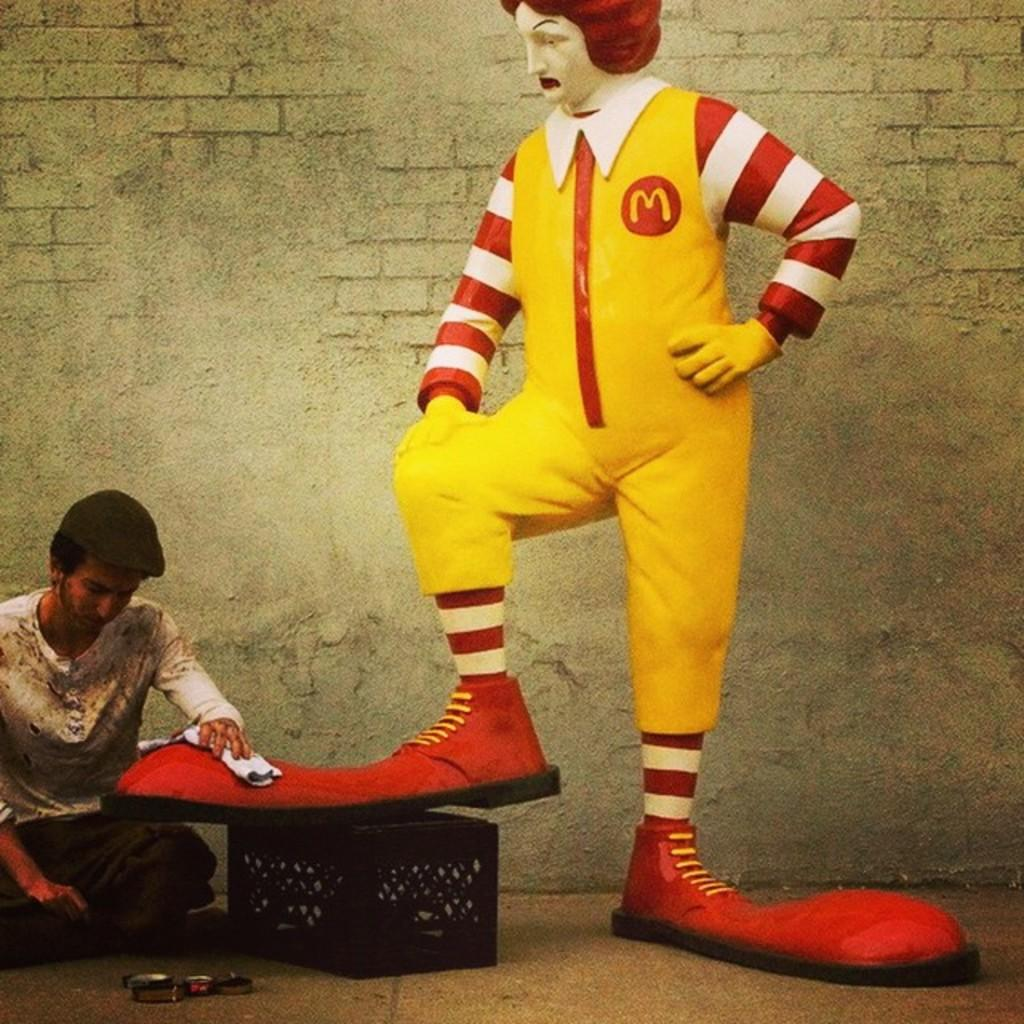What is the person in the image doing? The person is sitting on the ground in the image. What else can be seen on the ground in the image? There are many objects on the ground in the image. What type of artwork is present in the image? There is a sculpture in the image. What architectural feature can be seen in the image? There is a wall in the image. What type of insurance does the person sitting on the ground have in the image? There is no information about insurance in the image, as it focuses on the person sitting on the ground and the surrounding objects and features. 